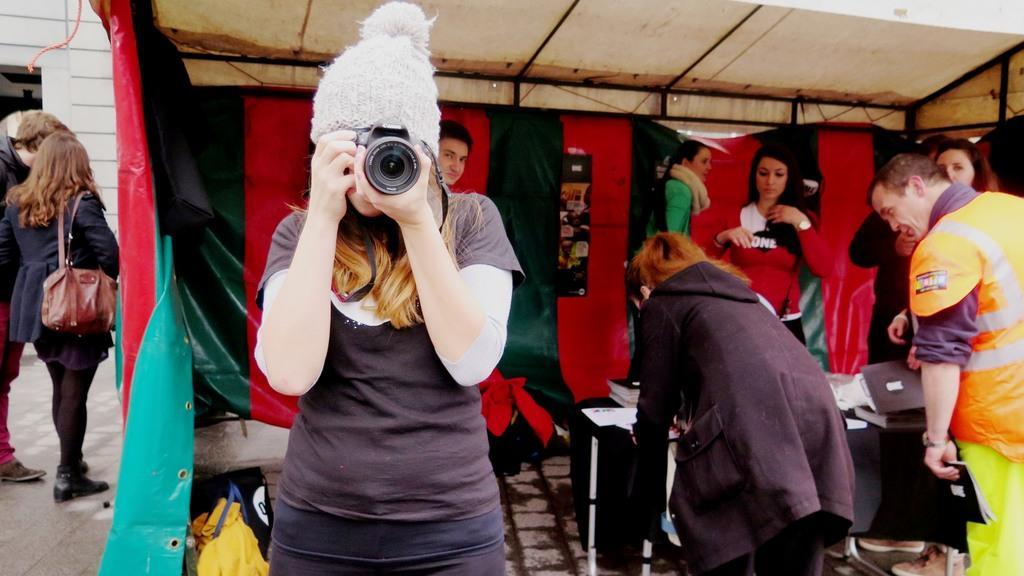Please provide a concise description of this image. This image consists of so many persons. There is a table on the right side. On that there are books and papers. In the middle there is a person who is clicking the pictures. There are some persons on the left side. 